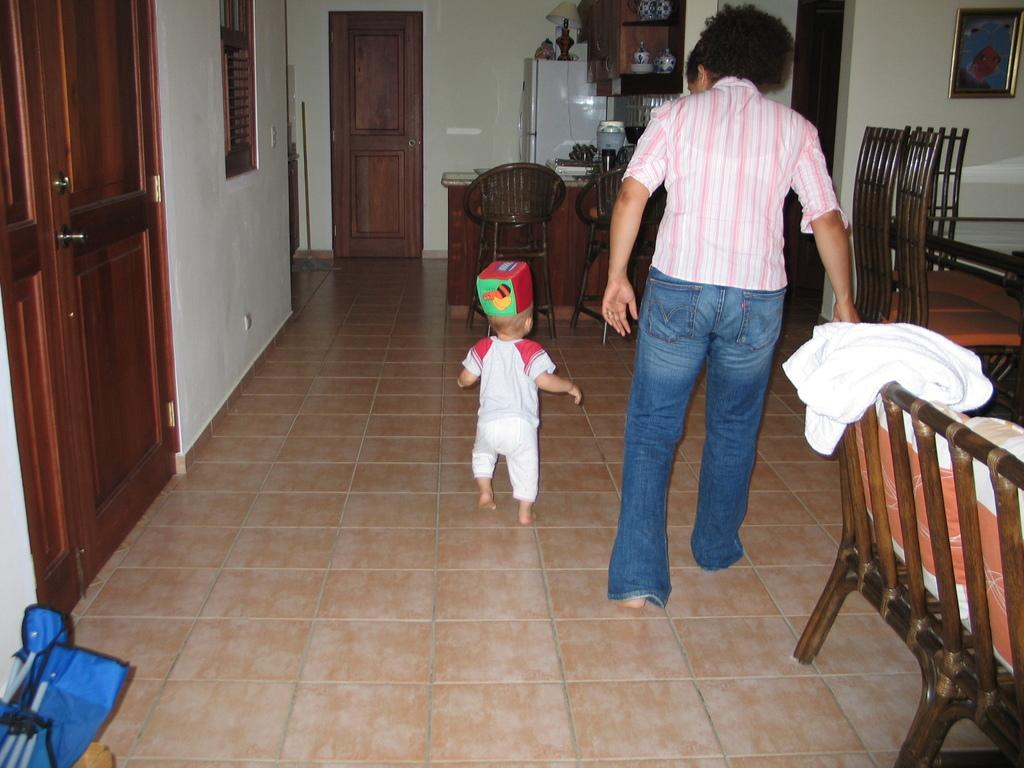What type of structure can be seen in the image? There is a wall in the image. Are there any openings in the wall? Yes, there is a door and a window in the image. What type of furniture is present in the image? There are chairs and a bench in the image. How many people are in the image? There are two people in the image. What type of cart is being used by the people in the image? There is no cart present in the image; it only features a wall, door, window, chairs, a bench, and two people. 